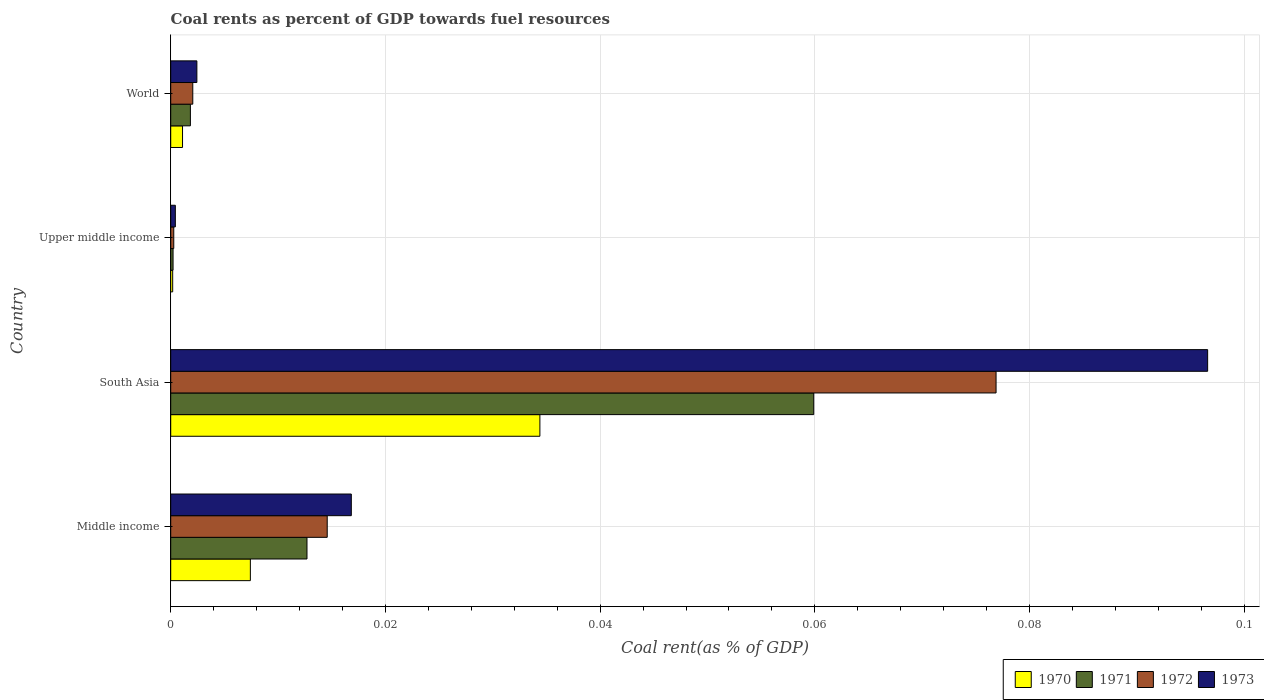How many different coloured bars are there?
Keep it short and to the point. 4. How many groups of bars are there?
Give a very brief answer. 4. Are the number of bars per tick equal to the number of legend labels?
Your answer should be very brief. Yes. How many bars are there on the 3rd tick from the top?
Give a very brief answer. 4. What is the label of the 4th group of bars from the top?
Provide a short and direct response. Middle income. In how many cases, is the number of bars for a given country not equal to the number of legend labels?
Provide a short and direct response. 0. What is the coal rent in 1972 in Middle income?
Keep it short and to the point. 0.01. Across all countries, what is the maximum coal rent in 1971?
Make the answer very short. 0.06. Across all countries, what is the minimum coal rent in 1972?
Offer a very short reply. 0. In which country was the coal rent in 1973 maximum?
Ensure brevity in your answer.  South Asia. In which country was the coal rent in 1970 minimum?
Offer a terse response. Upper middle income. What is the total coal rent in 1970 in the graph?
Your response must be concise. 0.04. What is the difference between the coal rent in 1971 in Middle income and that in World?
Offer a terse response. 0.01. What is the difference between the coal rent in 1972 in Middle income and the coal rent in 1973 in World?
Your response must be concise. 0.01. What is the average coal rent in 1970 per country?
Keep it short and to the point. 0.01. What is the difference between the coal rent in 1970 and coal rent in 1972 in South Asia?
Your answer should be very brief. -0.04. In how many countries, is the coal rent in 1972 greater than 0.08 %?
Your response must be concise. 0. What is the ratio of the coal rent in 1972 in South Asia to that in World?
Provide a succinct answer. 37.41. Is the difference between the coal rent in 1970 in South Asia and World greater than the difference between the coal rent in 1972 in South Asia and World?
Your answer should be very brief. No. What is the difference between the highest and the second highest coal rent in 1973?
Make the answer very short. 0.08. What is the difference between the highest and the lowest coal rent in 1971?
Offer a very short reply. 0.06. In how many countries, is the coal rent in 1970 greater than the average coal rent in 1970 taken over all countries?
Keep it short and to the point. 1. Is the sum of the coal rent in 1970 in Middle income and Upper middle income greater than the maximum coal rent in 1972 across all countries?
Your response must be concise. No. How many bars are there?
Ensure brevity in your answer.  16. What is the difference between two consecutive major ticks on the X-axis?
Your answer should be very brief. 0.02. Does the graph contain grids?
Offer a terse response. Yes. How are the legend labels stacked?
Offer a very short reply. Horizontal. What is the title of the graph?
Keep it short and to the point. Coal rents as percent of GDP towards fuel resources. What is the label or title of the X-axis?
Your answer should be very brief. Coal rent(as % of GDP). What is the label or title of the Y-axis?
Provide a succinct answer. Country. What is the Coal rent(as % of GDP) of 1970 in Middle income?
Your response must be concise. 0.01. What is the Coal rent(as % of GDP) of 1971 in Middle income?
Your response must be concise. 0.01. What is the Coal rent(as % of GDP) in 1972 in Middle income?
Your answer should be very brief. 0.01. What is the Coal rent(as % of GDP) in 1973 in Middle income?
Provide a short and direct response. 0.02. What is the Coal rent(as % of GDP) in 1970 in South Asia?
Your answer should be compact. 0.03. What is the Coal rent(as % of GDP) of 1971 in South Asia?
Your answer should be compact. 0.06. What is the Coal rent(as % of GDP) of 1972 in South Asia?
Offer a terse response. 0.08. What is the Coal rent(as % of GDP) of 1973 in South Asia?
Your answer should be very brief. 0.1. What is the Coal rent(as % of GDP) in 1970 in Upper middle income?
Offer a very short reply. 0. What is the Coal rent(as % of GDP) of 1971 in Upper middle income?
Offer a terse response. 0. What is the Coal rent(as % of GDP) of 1972 in Upper middle income?
Offer a terse response. 0. What is the Coal rent(as % of GDP) of 1973 in Upper middle income?
Offer a very short reply. 0. What is the Coal rent(as % of GDP) in 1970 in World?
Keep it short and to the point. 0. What is the Coal rent(as % of GDP) of 1971 in World?
Offer a terse response. 0. What is the Coal rent(as % of GDP) of 1972 in World?
Your response must be concise. 0. What is the Coal rent(as % of GDP) in 1973 in World?
Keep it short and to the point. 0. Across all countries, what is the maximum Coal rent(as % of GDP) in 1970?
Offer a very short reply. 0.03. Across all countries, what is the maximum Coal rent(as % of GDP) in 1971?
Offer a terse response. 0.06. Across all countries, what is the maximum Coal rent(as % of GDP) of 1972?
Ensure brevity in your answer.  0.08. Across all countries, what is the maximum Coal rent(as % of GDP) in 1973?
Provide a succinct answer. 0.1. Across all countries, what is the minimum Coal rent(as % of GDP) in 1970?
Provide a succinct answer. 0. Across all countries, what is the minimum Coal rent(as % of GDP) in 1971?
Your answer should be compact. 0. Across all countries, what is the minimum Coal rent(as % of GDP) in 1972?
Your response must be concise. 0. Across all countries, what is the minimum Coal rent(as % of GDP) of 1973?
Offer a terse response. 0. What is the total Coal rent(as % of GDP) of 1970 in the graph?
Offer a very short reply. 0.04. What is the total Coal rent(as % of GDP) of 1971 in the graph?
Your answer should be very brief. 0.07. What is the total Coal rent(as % of GDP) of 1972 in the graph?
Provide a short and direct response. 0.09. What is the total Coal rent(as % of GDP) in 1973 in the graph?
Your answer should be very brief. 0.12. What is the difference between the Coal rent(as % of GDP) of 1970 in Middle income and that in South Asia?
Give a very brief answer. -0.03. What is the difference between the Coal rent(as % of GDP) of 1971 in Middle income and that in South Asia?
Keep it short and to the point. -0.05. What is the difference between the Coal rent(as % of GDP) of 1972 in Middle income and that in South Asia?
Give a very brief answer. -0.06. What is the difference between the Coal rent(as % of GDP) in 1973 in Middle income and that in South Asia?
Make the answer very short. -0.08. What is the difference between the Coal rent(as % of GDP) in 1970 in Middle income and that in Upper middle income?
Make the answer very short. 0.01. What is the difference between the Coal rent(as % of GDP) in 1971 in Middle income and that in Upper middle income?
Offer a terse response. 0.01. What is the difference between the Coal rent(as % of GDP) of 1972 in Middle income and that in Upper middle income?
Make the answer very short. 0.01. What is the difference between the Coal rent(as % of GDP) in 1973 in Middle income and that in Upper middle income?
Make the answer very short. 0.02. What is the difference between the Coal rent(as % of GDP) of 1970 in Middle income and that in World?
Offer a terse response. 0.01. What is the difference between the Coal rent(as % of GDP) of 1971 in Middle income and that in World?
Your answer should be compact. 0.01. What is the difference between the Coal rent(as % of GDP) in 1972 in Middle income and that in World?
Ensure brevity in your answer.  0.01. What is the difference between the Coal rent(as % of GDP) of 1973 in Middle income and that in World?
Offer a terse response. 0.01. What is the difference between the Coal rent(as % of GDP) in 1970 in South Asia and that in Upper middle income?
Your answer should be very brief. 0.03. What is the difference between the Coal rent(as % of GDP) in 1971 in South Asia and that in Upper middle income?
Your answer should be very brief. 0.06. What is the difference between the Coal rent(as % of GDP) in 1972 in South Asia and that in Upper middle income?
Give a very brief answer. 0.08. What is the difference between the Coal rent(as % of GDP) in 1973 in South Asia and that in Upper middle income?
Offer a very short reply. 0.1. What is the difference between the Coal rent(as % of GDP) of 1971 in South Asia and that in World?
Your answer should be very brief. 0.06. What is the difference between the Coal rent(as % of GDP) of 1972 in South Asia and that in World?
Offer a terse response. 0.07. What is the difference between the Coal rent(as % of GDP) in 1973 in South Asia and that in World?
Give a very brief answer. 0.09. What is the difference between the Coal rent(as % of GDP) of 1970 in Upper middle income and that in World?
Provide a succinct answer. -0. What is the difference between the Coal rent(as % of GDP) of 1971 in Upper middle income and that in World?
Provide a short and direct response. -0. What is the difference between the Coal rent(as % of GDP) of 1972 in Upper middle income and that in World?
Your response must be concise. -0. What is the difference between the Coal rent(as % of GDP) in 1973 in Upper middle income and that in World?
Ensure brevity in your answer.  -0. What is the difference between the Coal rent(as % of GDP) of 1970 in Middle income and the Coal rent(as % of GDP) of 1971 in South Asia?
Keep it short and to the point. -0.05. What is the difference between the Coal rent(as % of GDP) of 1970 in Middle income and the Coal rent(as % of GDP) of 1972 in South Asia?
Offer a terse response. -0.07. What is the difference between the Coal rent(as % of GDP) of 1970 in Middle income and the Coal rent(as % of GDP) of 1973 in South Asia?
Offer a very short reply. -0.09. What is the difference between the Coal rent(as % of GDP) of 1971 in Middle income and the Coal rent(as % of GDP) of 1972 in South Asia?
Ensure brevity in your answer.  -0.06. What is the difference between the Coal rent(as % of GDP) of 1971 in Middle income and the Coal rent(as % of GDP) of 1973 in South Asia?
Your response must be concise. -0.08. What is the difference between the Coal rent(as % of GDP) in 1972 in Middle income and the Coal rent(as % of GDP) in 1973 in South Asia?
Provide a short and direct response. -0.08. What is the difference between the Coal rent(as % of GDP) of 1970 in Middle income and the Coal rent(as % of GDP) of 1971 in Upper middle income?
Your answer should be compact. 0.01. What is the difference between the Coal rent(as % of GDP) of 1970 in Middle income and the Coal rent(as % of GDP) of 1972 in Upper middle income?
Make the answer very short. 0.01. What is the difference between the Coal rent(as % of GDP) of 1970 in Middle income and the Coal rent(as % of GDP) of 1973 in Upper middle income?
Your answer should be very brief. 0.01. What is the difference between the Coal rent(as % of GDP) in 1971 in Middle income and the Coal rent(as % of GDP) in 1972 in Upper middle income?
Your answer should be very brief. 0.01. What is the difference between the Coal rent(as % of GDP) in 1971 in Middle income and the Coal rent(as % of GDP) in 1973 in Upper middle income?
Your response must be concise. 0.01. What is the difference between the Coal rent(as % of GDP) of 1972 in Middle income and the Coal rent(as % of GDP) of 1973 in Upper middle income?
Make the answer very short. 0.01. What is the difference between the Coal rent(as % of GDP) of 1970 in Middle income and the Coal rent(as % of GDP) of 1971 in World?
Provide a succinct answer. 0.01. What is the difference between the Coal rent(as % of GDP) in 1970 in Middle income and the Coal rent(as % of GDP) in 1972 in World?
Make the answer very short. 0.01. What is the difference between the Coal rent(as % of GDP) of 1970 in Middle income and the Coal rent(as % of GDP) of 1973 in World?
Your response must be concise. 0.01. What is the difference between the Coal rent(as % of GDP) in 1971 in Middle income and the Coal rent(as % of GDP) in 1972 in World?
Provide a short and direct response. 0.01. What is the difference between the Coal rent(as % of GDP) of 1971 in Middle income and the Coal rent(as % of GDP) of 1973 in World?
Your answer should be very brief. 0.01. What is the difference between the Coal rent(as % of GDP) of 1972 in Middle income and the Coal rent(as % of GDP) of 1973 in World?
Offer a very short reply. 0.01. What is the difference between the Coal rent(as % of GDP) of 1970 in South Asia and the Coal rent(as % of GDP) of 1971 in Upper middle income?
Make the answer very short. 0.03. What is the difference between the Coal rent(as % of GDP) of 1970 in South Asia and the Coal rent(as % of GDP) of 1972 in Upper middle income?
Make the answer very short. 0.03. What is the difference between the Coal rent(as % of GDP) in 1970 in South Asia and the Coal rent(as % of GDP) in 1973 in Upper middle income?
Your answer should be compact. 0.03. What is the difference between the Coal rent(as % of GDP) of 1971 in South Asia and the Coal rent(as % of GDP) of 1972 in Upper middle income?
Provide a succinct answer. 0.06. What is the difference between the Coal rent(as % of GDP) in 1971 in South Asia and the Coal rent(as % of GDP) in 1973 in Upper middle income?
Give a very brief answer. 0.06. What is the difference between the Coal rent(as % of GDP) of 1972 in South Asia and the Coal rent(as % of GDP) of 1973 in Upper middle income?
Your response must be concise. 0.08. What is the difference between the Coal rent(as % of GDP) of 1970 in South Asia and the Coal rent(as % of GDP) of 1971 in World?
Provide a succinct answer. 0.03. What is the difference between the Coal rent(as % of GDP) of 1970 in South Asia and the Coal rent(as % of GDP) of 1972 in World?
Keep it short and to the point. 0.03. What is the difference between the Coal rent(as % of GDP) of 1970 in South Asia and the Coal rent(as % of GDP) of 1973 in World?
Give a very brief answer. 0.03. What is the difference between the Coal rent(as % of GDP) of 1971 in South Asia and the Coal rent(as % of GDP) of 1972 in World?
Ensure brevity in your answer.  0.06. What is the difference between the Coal rent(as % of GDP) of 1971 in South Asia and the Coal rent(as % of GDP) of 1973 in World?
Ensure brevity in your answer.  0.06. What is the difference between the Coal rent(as % of GDP) in 1972 in South Asia and the Coal rent(as % of GDP) in 1973 in World?
Provide a succinct answer. 0.07. What is the difference between the Coal rent(as % of GDP) of 1970 in Upper middle income and the Coal rent(as % of GDP) of 1971 in World?
Provide a succinct answer. -0. What is the difference between the Coal rent(as % of GDP) of 1970 in Upper middle income and the Coal rent(as % of GDP) of 1972 in World?
Make the answer very short. -0. What is the difference between the Coal rent(as % of GDP) in 1970 in Upper middle income and the Coal rent(as % of GDP) in 1973 in World?
Your response must be concise. -0. What is the difference between the Coal rent(as % of GDP) in 1971 in Upper middle income and the Coal rent(as % of GDP) in 1972 in World?
Provide a succinct answer. -0. What is the difference between the Coal rent(as % of GDP) of 1971 in Upper middle income and the Coal rent(as % of GDP) of 1973 in World?
Ensure brevity in your answer.  -0. What is the difference between the Coal rent(as % of GDP) of 1972 in Upper middle income and the Coal rent(as % of GDP) of 1973 in World?
Your response must be concise. -0. What is the average Coal rent(as % of GDP) of 1970 per country?
Your response must be concise. 0.01. What is the average Coal rent(as % of GDP) of 1971 per country?
Keep it short and to the point. 0.02. What is the average Coal rent(as % of GDP) in 1972 per country?
Offer a very short reply. 0.02. What is the average Coal rent(as % of GDP) of 1973 per country?
Make the answer very short. 0.03. What is the difference between the Coal rent(as % of GDP) of 1970 and Coal rent(as % of GDP) of 1971 in Middle income?
Provide a succinct answer. -0.01. What is the difference between the Coal rent(as % of GDP) of 1970 and Coal rent(as % of GDP) of 1972 in Middle income?
Offer a very short reply. -0.01. What is the difference between the Coal rent(as % of GDP) in 1970 and Coal rent(as % of GDP) in 1973 in Middle income?
Give a very brief answer. -0.01. What is the difference between the Coal rent(as % of GDP) in 1971 and Coal rent(as % of GDP) in 1972 in Middle income?
Provide a short and direct response. -0. What is the difference between the Coal rent(as % of GDP) in 1971 and Coal rent(as % of GDP) in 1973 in Middle income?
Make the answer very short. -0. What is the difference between the Coal rent(as % of GDP) of 1972 and Coal rent(as % of GDP) of 1973 in Middle income?
Provide a succinct answer. -0. What is the difference between the Coal rent(as % of GDP) of 1970 and Coal rent(as % of GDP) of 1971 in South Asia?
Provide a succinct answer. -0.03. What is the difference between the Coal rent(as % of GDP) in 1970 and Coal rent(as % of GDP) in 1972 in South Asia?
Offer a very short reply. -0.04. What is the difference between the Coal rent(as % of GDP) in 1970 and Coal rent(as % of GDP) in 1973 in South Asia?
Your response must be concise. -0.06. What is the difference between the Coal rent(as % of GDP) of 1971 and Coal rent(as % of GDP) of 1972 in South Asia?
Give a very brief answer. -0.02. What is the difference between the Coal rent(as % of GDP) of 1971 and Coal rent(as % of GDP) of 1973 in South Asia?
Your answer should be compact. -0.04. What is the difference between the Coal rent(as % of GDP) of 1972 and Coal rent(as % of GDP) of 1973 in South Asia?
Offer a very short reply. -0.02. What is the difference between the Coal rent(as % of GDP) in 1970 and Coal rent(as % of GDP) in 1972 in Upper middle income?
Offer a very short reply. -0. What is the difference between the Coal rent(as % of GDP) in 1970 and Coal rent(as % of GDP) in 1973 in Upper middle income?
Your answer should be compact. -0. What is the difference between the Coal rent(as % of GDP) of 1971 and Coal rent(as % of GDP) of 1972 in Upper middle income?
Your answer should be compact. -0. What is the difference between the Coal rent(as % of GDP) in 1971 and Coal rent(as % of GDP) in 1973 in Upper middle income?
Ensure brevity in your answer.  -0. What is the difference between the Coal rent(as % of GDP) in 1972 and Coal rent(as % of GDP) in 1973 in Upper middle income?
Give a very brief answer. -0. What is the difference between the Coal rent(as % of GDP) in 1970 and Coal rent(as % of GDP) in 1971 in World?
Your answer should be compact. -0. What is the difference between the Coal rent(as % of GDP) in 1970 and Coal rent(as % of GDP) in 1972 in World?
Make the answer very short. -0. What is the difference between the Coal rent(as % of GDP) in 1970 and Coal rent(as % of GDP) in 1973 in World?
Offer a terse response. -0. What is the difference between the Coal rent(as % of GDP) of 1971 and Coal rent(as % of GDP) of 1972 in World?
Your response must be concise. -0. What is the difference between the Coal rent(as % of GDP) in 1971 and Coal rent(as % of GDP) in 1973 in World?
Your response must be concise. -0. What is the difference between the Coal rent(as % of GDP) of 1972 and Coal rent(as % of GDP) of 1973 in World?
Provide a succinct answer. -0. What is the ratio of the Coal rent(as % of GDP) of 1970 in Middle income to that in South Asia?
Provide a succinct answer. 0.22. What is the ratio of the Coal rent(as % of GDP) of 1971 in Middle income to that in South Asia?
Provide a succinct answer. 0.21. What is the ratio of the Coal rent(as % of GDP) of 1972 in Middle income to that in South Asia?
Your answer should be very brief. 0.19. What is the ratio of the Coal rent(as % of GDP) in 1973 in Middle income to that in South Asia?
Ensure brevity in your answer.  0.17. What is the ratio of the Coal rent(as % of GDP) in 1970 in Middle income to that in Upper middle income?
Make the answer very short. 40.36. What is the ratio of the Coal rent(as % of GDP) in 1971 in Middle income to that in Upper middle income?
Your answer should be compact. 58.01. What is the ratio of the Coal rent(as % of GDP) of 1972 in Middle income to that in Upper middle income?
Your answer should be very brief. 51.25. What is the ratio of the Coal rent(as % of GDP) of 1973 in Middle income to that in Upper middle income?
Provide a succinct answer. 39.04. What is the ratio of the Coal rent(as % of GDP) in 1970 in Middle income to that in World?
Your answer should be very brief. 6.74. What is the ratio of the Coal rent(as % of GDP) of 1971 in Middle income to that in World?
Provide a short and direct response. 6.93. What is the ratio of the Coal rent(as % of GDP) of 1972 in Middle income to that in World?
Your answer should be very brief. 7.09. What is the ratio of the Coal rent(as % of GDP) of 1973 in Middle income to that in World?
Your response must be concise. 6.91. What is the ratio of the Coal rent(as % of GDP) of 1970 in South Asia to that in Upper middle income?
Give a very brief answer. 187.05. What is the ratio of the Coal rent(as % of GDP) of 1971 in South Asia to that in Upper middle income?
Provide a short and direct response. 273.74. What is the ratio of the Coal rent(as % of GDP) in 1972 in South Asia to that in Upper middle income?
Give a very brief answer. 270.32. What is the ratio of the Coal rent(as % of GDP) in 1973 in South Asia to that in Upper middle income?
Your answer should be very brief. 224.18. What is the ratio of the Coal rent(as % of GDP) of 1970 in South Asia to that in World?
Provide a short and direct response. 31.24. What is the ratio of the Coal rent(as % of GDP) in 1971 in South Asia to that in World?
Make the answer very short. 32.69. What is the ratio of the Coal rent(as % of GDP) in 1972 in South Asia to that in World?
Provide a short and direct response. 37.41. What is the ratio of the Coal rent(as % of GDP) in 1973 in South Asia to that in World?
Ensure brevity in your answer.  39.65. What is the ratio of the Coal rent(as % of GDP) of 1970 in Upper middle income to that in World?
Provide a succinct answer. 0.17. What is the ratio of the Coal rent(as % of GDP) in 1971 in Upper middle income to that in World?
Provide a succinct answer. 0.12. What is the ratio of the Coal rent(as % of GDP) of 1972 in Upper middle income to that in World?
Make the answer very short. 0.14. What is the ratio of the Coal rent(as % of GDP) of 1973 in Upper middle income to that in World?
Provide a succinct answer. 0.18. What is the difference between the highest and the second highest Coal rent(as % of GDP) of 1970?
Your answer should be very brief. 0.03. What is the difference between the highest and the second highest Coal rent(as % of GDP) in 1971?
Make the answer very short. 0.05. What is the difference between the highest and the second highest Coal rent(as % of GDP) in 1972?
Offer a very short reply. 0.06. What is the difference between the highest and the second highest Coal rent(as % of GDP) of 1973?
Your response must be concise. 0.08. What is the difference between the highest and the lowest Coal rent(as % of GDP) of 1970?
Give a very brief answer. 0.03. What is the difference between the highest and the lowest Coal rent(as % of GDP) in 1971?
Your answer should be very brief. 0.06. What is the difference between the highest and the lowest Coal rent(as % of GDP) in 1972?
Ensure brevity in your answer.  0.08. What is the difference between the highest and the lowest Coal rent(as % of GDP) of 1973?
Your answer should be compact. 0.1. 